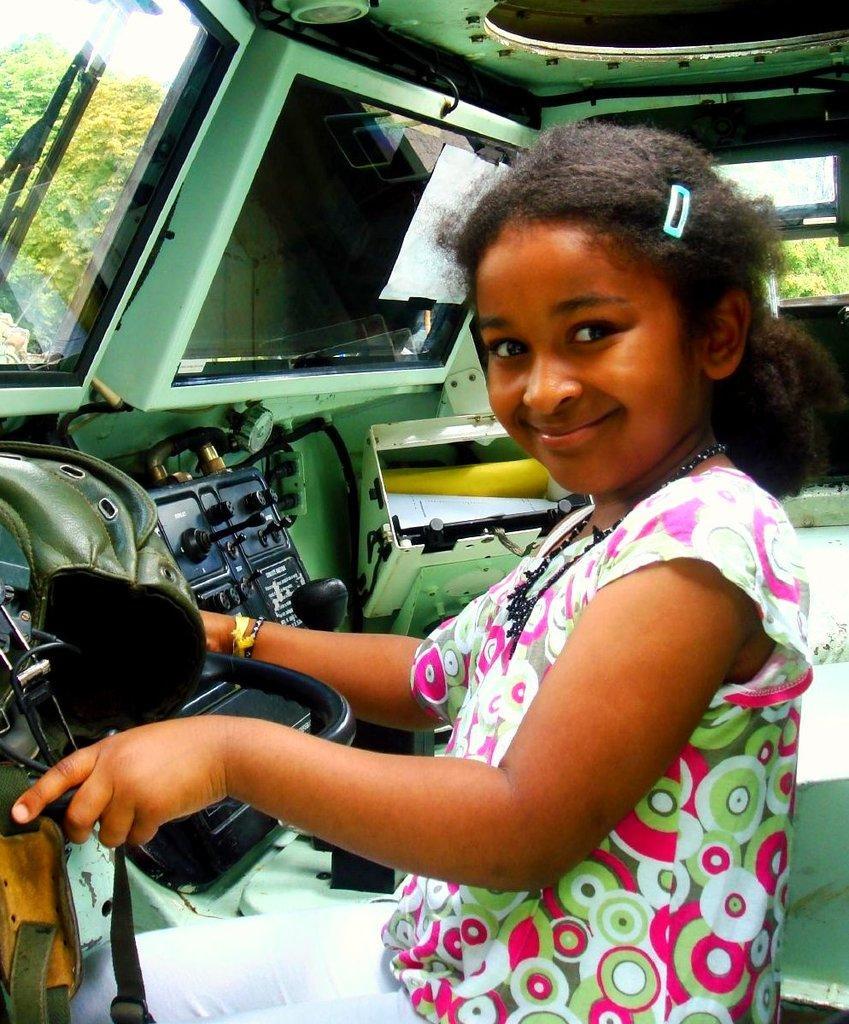How would you summarize this image in a sentence or two? This is the picture of a girl wearing white pant and top she is sitting inside a vehicle and holding an object and posing for a photo. In the background, we can see a few trees. 